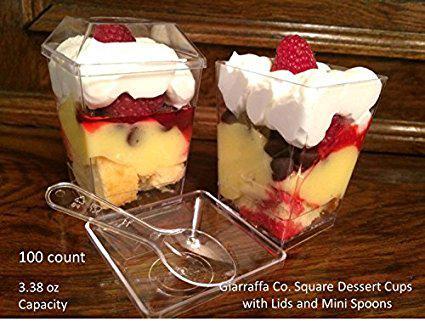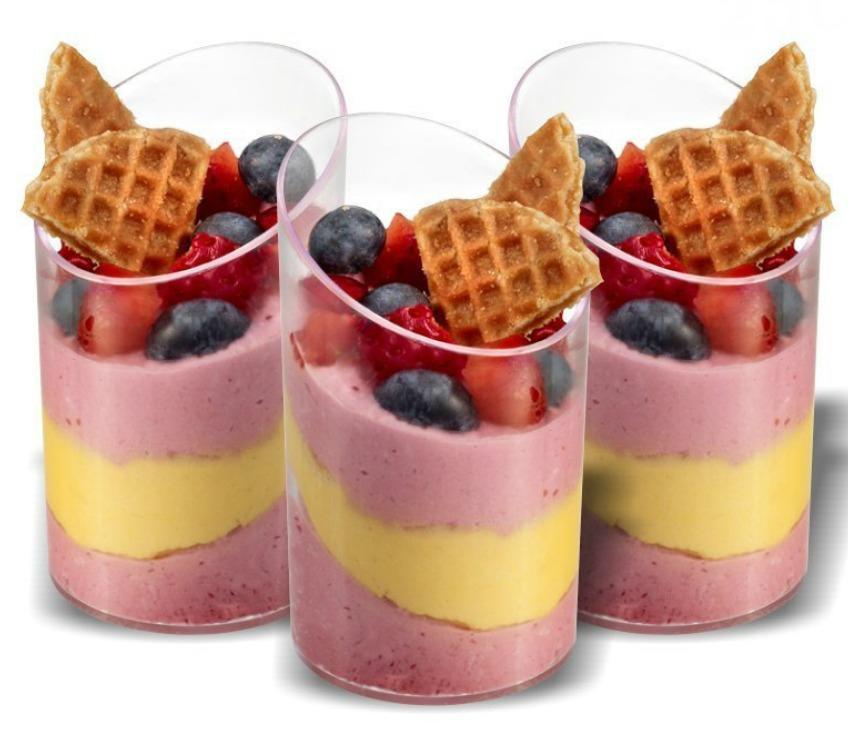The first image is the image on the left, the second image is the image on the right. Examine the images to the left and right. Is the description "there are blueberries on the top of the dessert on the right" accurate? Answer yes or no. Yes. 